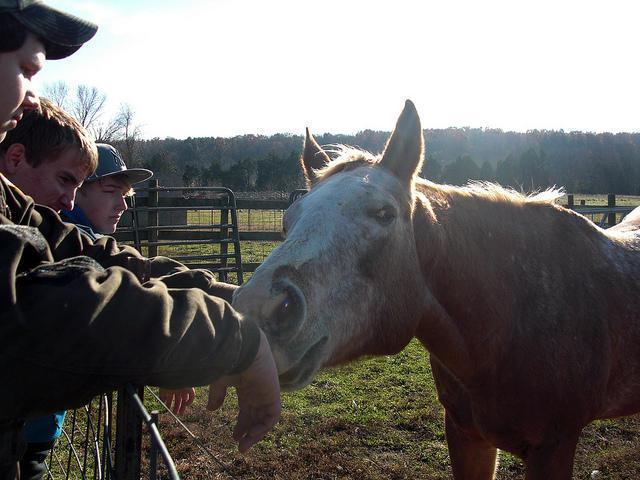How many eyes are shown?
Give a very brief answer. 4. How many people can you see?
Give a very brief answer. 3. How many birds are there?
Give a very brief answer. 0. 